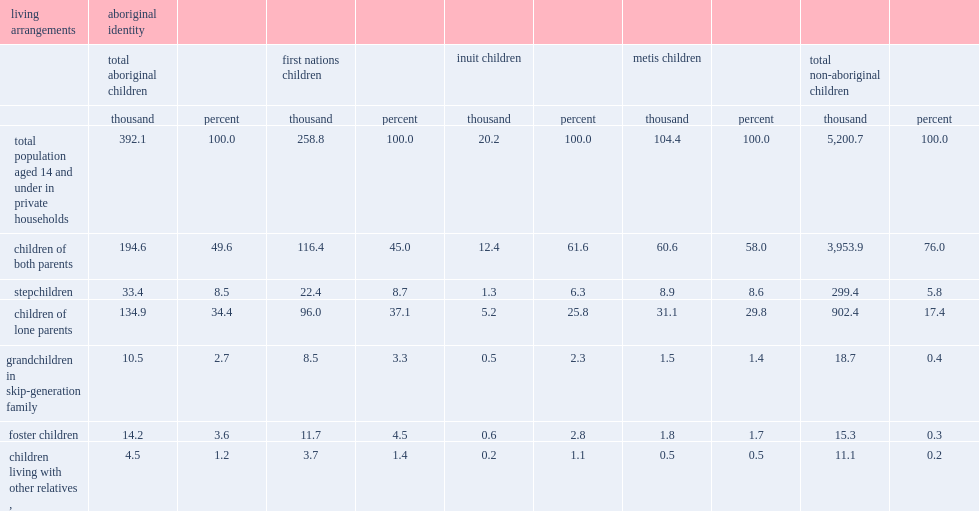According to the 2011 nhs, how many aboriginal children were aged 14 and under in canada? 392.1. What was the percent of aboriginal children aged 14 and under lived in a family with both parents (biological or adoptive)? 49.6. What was the percent of their non-aboriginal counterparts aged 14 and under lived in a family with both parents (biological or adoptive)? 76.0. Which type of households had higher proportion, aboriginal children living with a lone parent or non-aboriginal children? Children of lone parents. Which type of children were more likely to be stepchildren, aboriginal children or non-aboriginal counterparts? Total aboriginal children. Which type of children were more likely to be foster children, aboriginal children or non-aboriginal counterparts? Total aboriginal children. Which type of children were more likely to live with grandparents in a skip-generation household, aboriginal children or non-aboriginal counterparts? Total aboriginal children. 